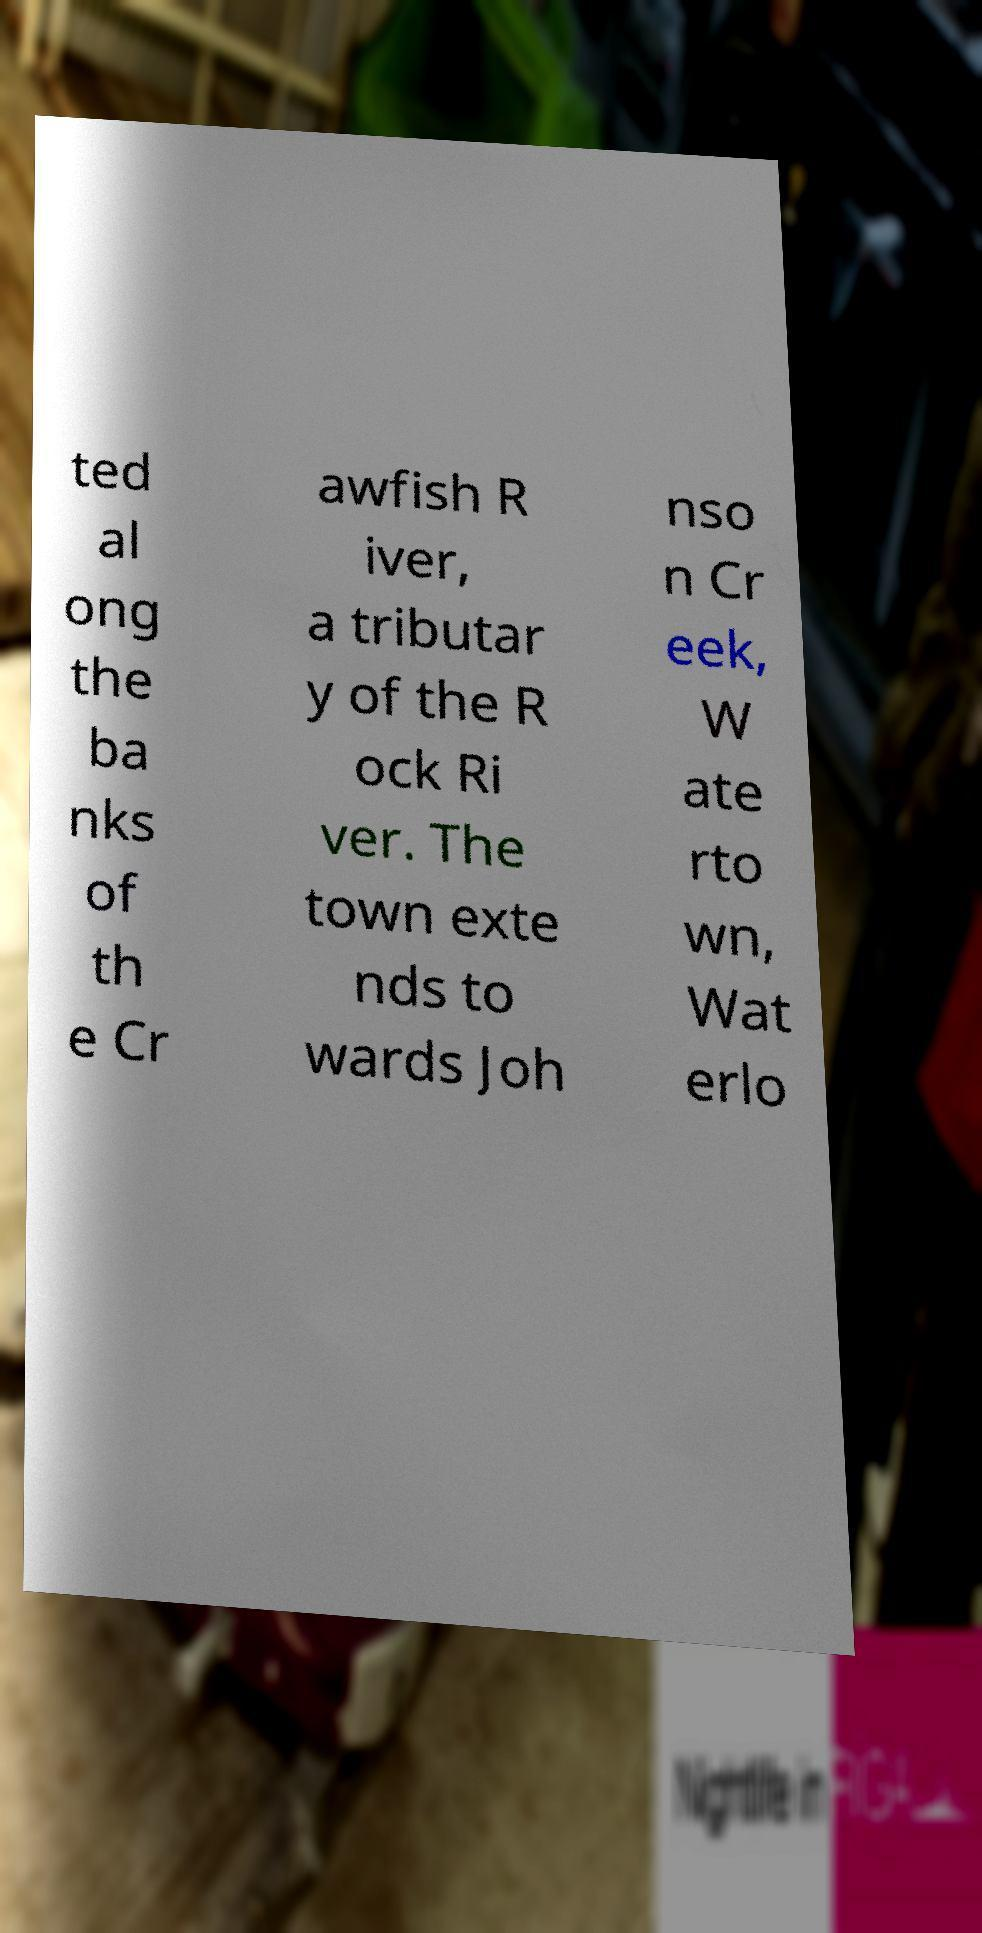I need the written content from this picture converted into text. Can you do that? ted al ong the ba nks of th e Cr awfish R iver, a tributar y of the R ock Ri ver. The town exte nds to wards Joh nso n Cr eek, W ate rto wn, Wat erlo 